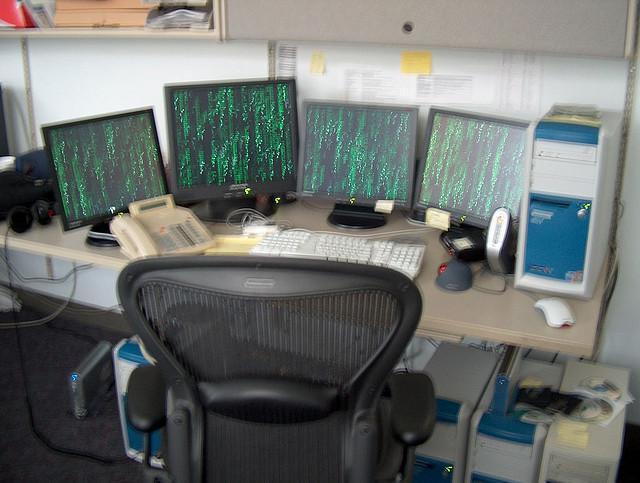How many monitors are on the desk?
Give a very brief answer. 4. How many computers are there?
Give a very brief answer. 4. How many monitors are there?
Give a very brief answer. 4. How many tvs are visible?
Give a very brief answer. 3. 